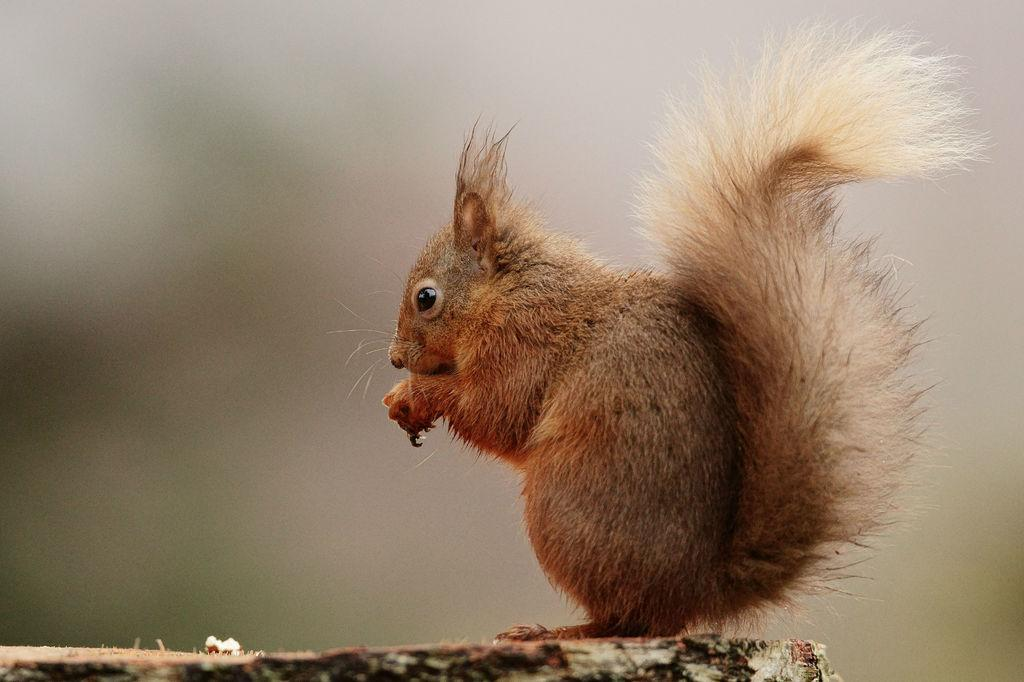Where was the image taken? The image was clicked outside. What animal can be seen in the image? There is a squirrel in the image. What is the squirrel doing in the image? The squirrel is standing on an object. Can you describe the background of the image? The background of the image is blurry. What type of crib is visible in the image? There is no crib present in the image. Is the squirrel sailing on a boat in the image? There is no boat present in the image, and the squirrel is standing on an object, not sailing. 